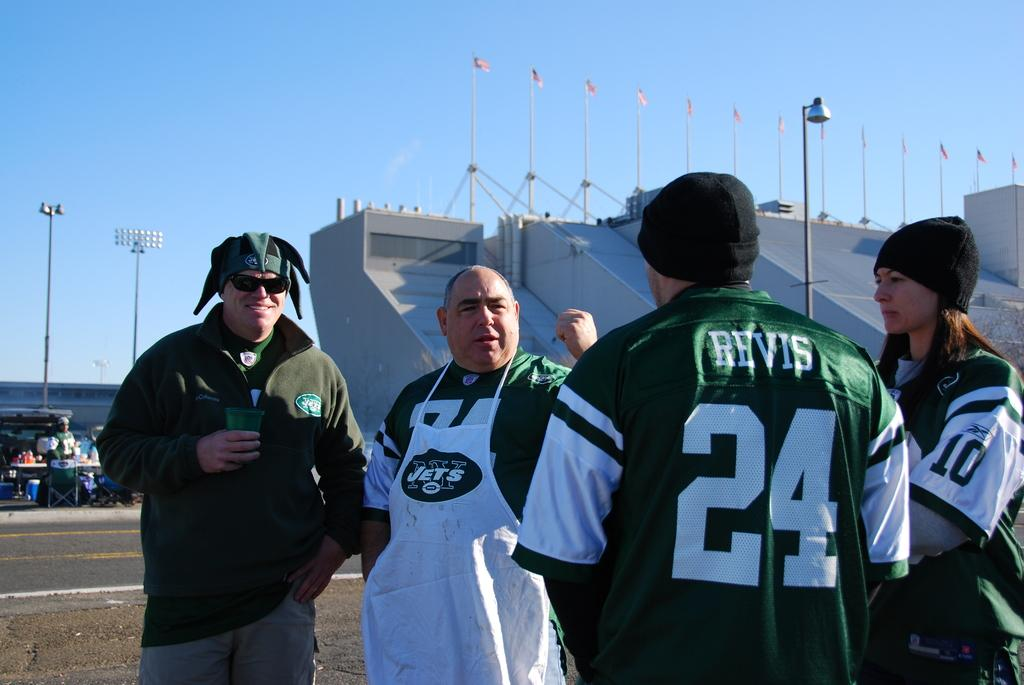Provide a one-sentence caption for the provided image. a group of jets fans standing in front of the stadium. 